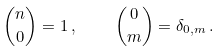Convert formula to latex. <formula><loc_0><loc_0><loc_500><loc_500>\binom { n } { 0 } = 1 \, , \quad \binom { 0 } { m } = \delta _ { 0 , m } \, .</formula> 